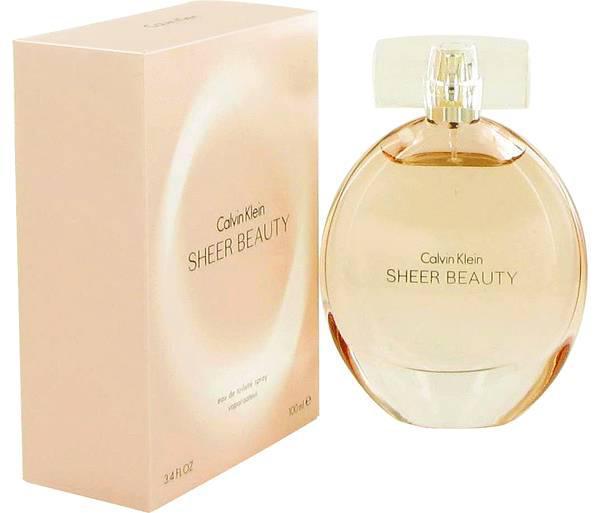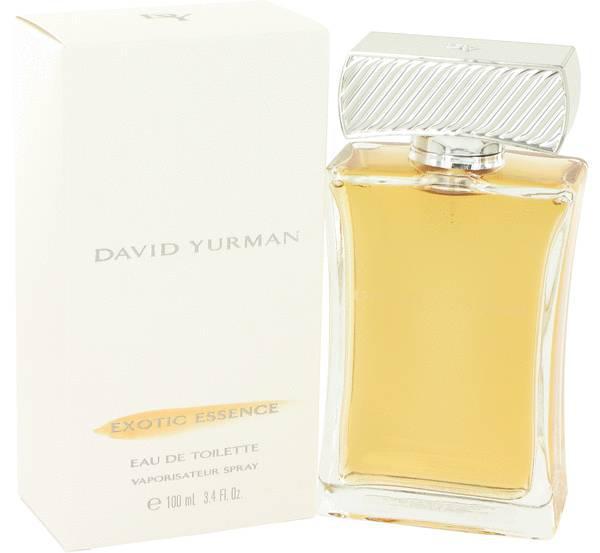The first image is the image on the left, the second image is the image on the right. For the images shown, is this caption "There is a round perfume bottle on the left." true? Answer yes or no. Yes. 